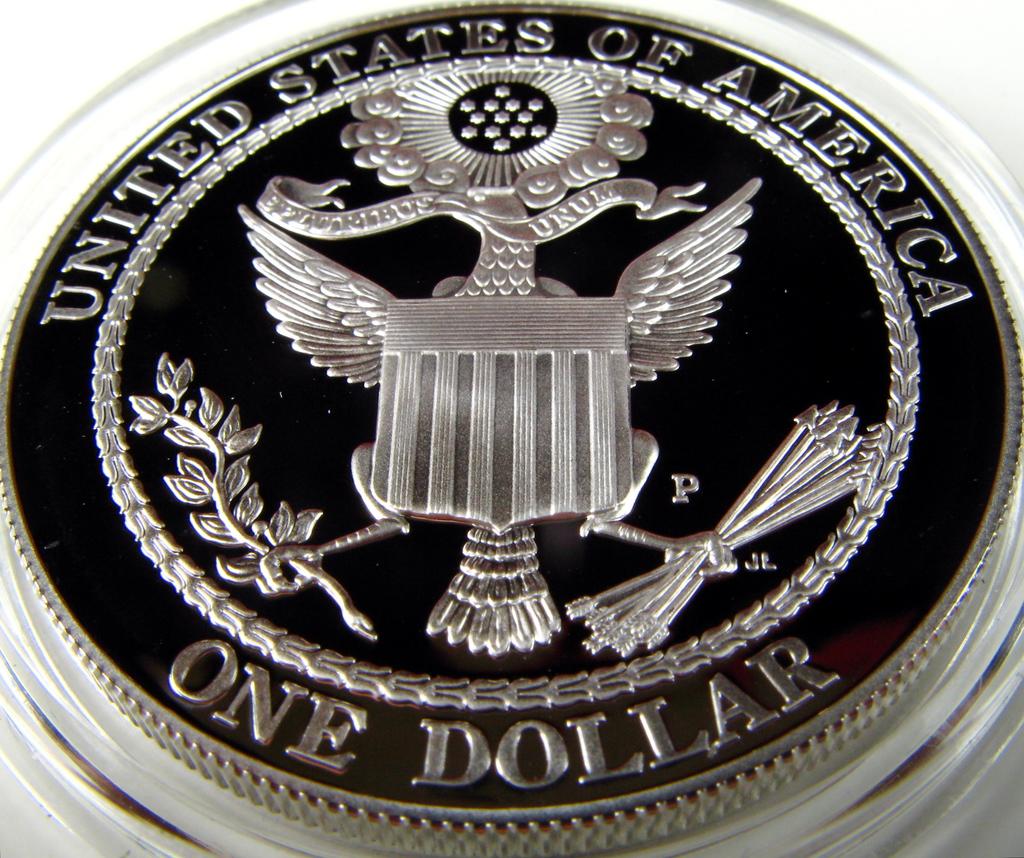In what country is this currency made?
Keep it short and to the point. United states of america. Is thia a dollar coin?
Your answer should be compact. Yes. 